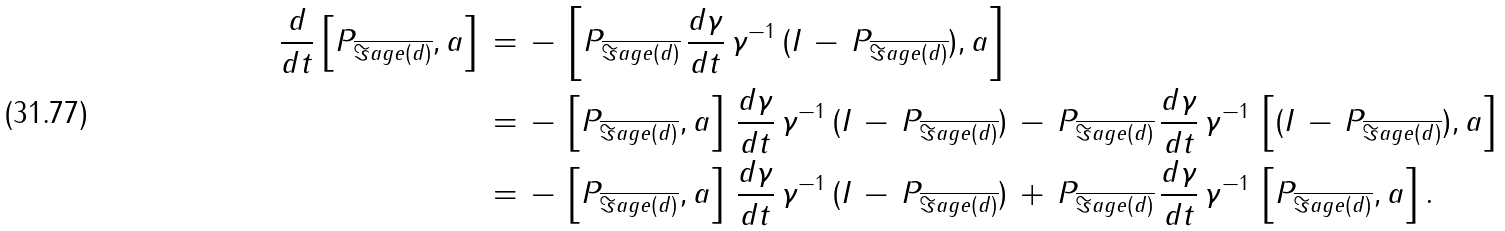<formula> <loc_0><loc_0><loc_500><loc_500>\frac { d } { d t } \left [ P _ { \overline { \Im a g e ( d ) } } , a \right ] \, & = \, - \, \left [ P _ { \overline { \Im a g e ( d ) } } \, \frac { d \gamma } { d t } \, \gamma ^ { - 1 } \, ( I \, - \, P _ { \overline { \Im a g e ( d ) } } ) , a \right ] \\ & = \, - \, \left [ P _ { \overline { \Im a g e ( d ) } } , a \right ] \, \frac { d \gamma } { d t } \, \gamma ^ { - 1 } \, ( I \, - \, P _ { \overline { \Im a g e ( d ) } } ) \, - \, P _ { \overline { \Im a g e ( d ) } } \, \frac { d \gamma } { d t } \, \gamma ^ { - 1 } \, \left [ ( I \, - \, P _ { \overline { \Im a g e ( d ) } } ) , a \right ] \\ & = \, - \, \left [ P _ { \overline { \Im a g e ( d ) } } , a \right ] \, \frac { d \gamma } { d t } \, \gamma ^ { - 1 } \, ( I \, - \, P _ { \overline { \Im a g e ( d ) } } ) \, + \, P _ { \overline { \Im a g e ( d ) } } \, \frac { d \gamma } { d t } \, \gamma ^ { - 1 } \, \left [ P _ { \overline { \Im a g e ( d ) } } , a \right ] .</formula> 